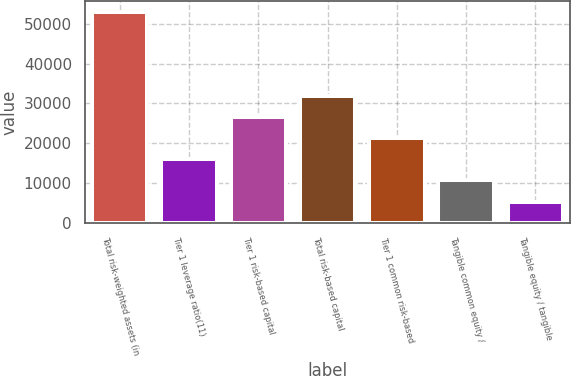<chart> <loc_0><loc_0><loc_500><loc_500><bar_chart><fcel>Total risk-weighted assets (in<fcel>Tier 1 leverage ratio(11)<fcel>Tier 1 risk-based capital<fcel>Total risk-based capital<fcel>Tier 1 common risk-based<fcel>Tangible common equity /<fcel>Tangible equity / tangible<nl><fcel>53035<fcel>15916.4<fcel>26521.7<fcel>31824.3<fcel>21219<fcel>10613.7<fcel>5311.04<nl></chart> 